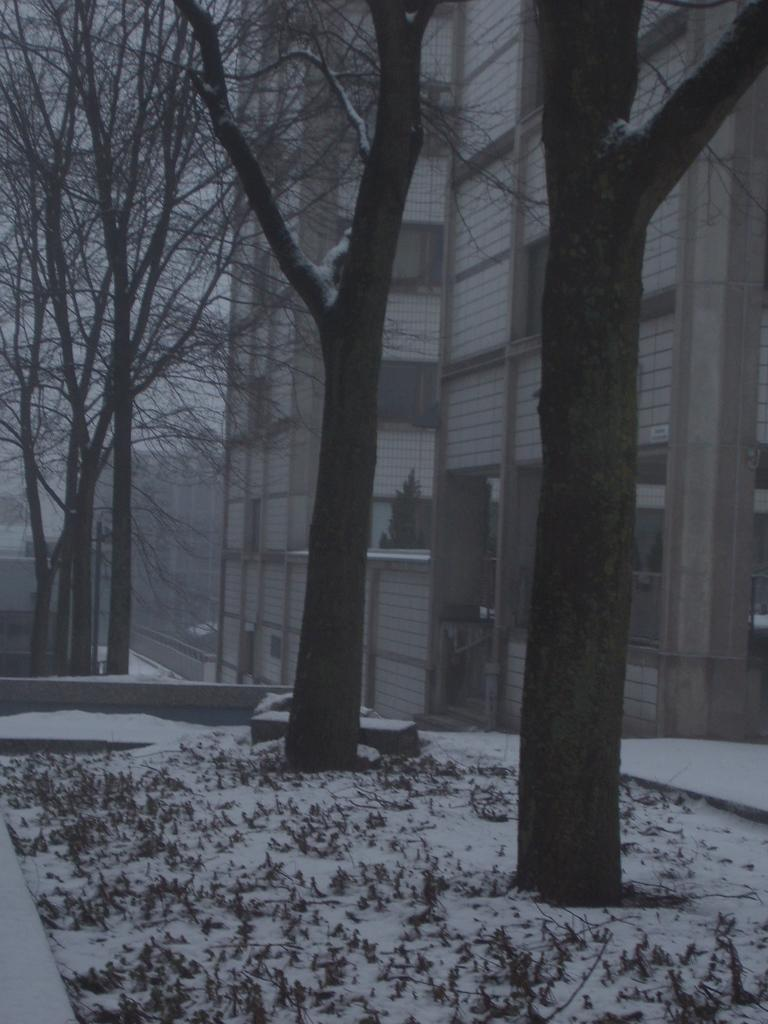What type of vegetation is present in the image? There are many trees in the image. What can be seen behind the trees? There are buildings visible behind the trees. What is visible in the top left of the image? The sky is visible in the top left of the image. What type of ground cover is at the bottom of the image? There is grass and snow at the bottom of the image. What type of wine is being served in the image? There is no wine present in the image. Is there a bucket visible in the image? There is no bucket present in the image. 